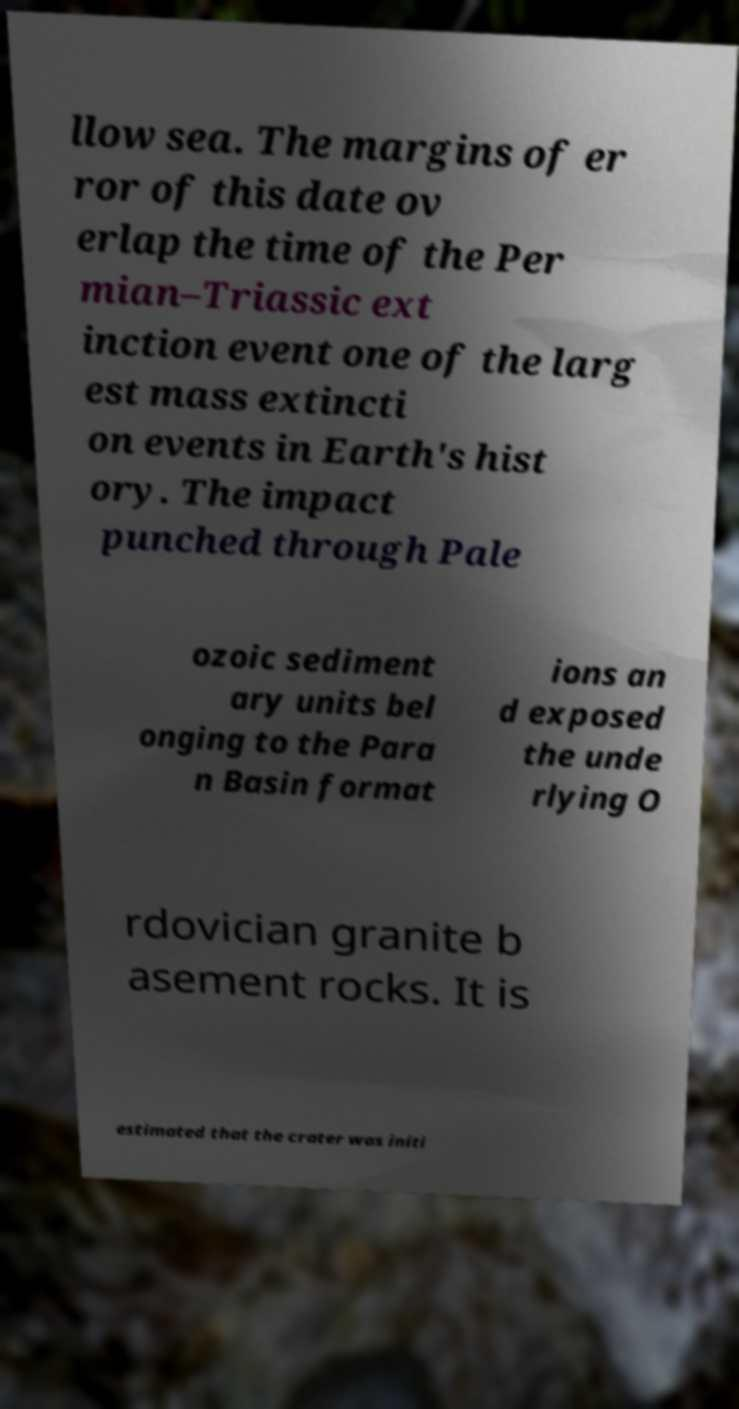There's text embedded in this image that I need extracted. Can you transcribe it verbatim? llow sea. The margins of er ror of this date ov erlap the time of the Per mian–Triassic ext inction event one of the larg est mass extincti on events in Earth's hist ory. The impact punched through Pale ozoic sediment ary units bel onging to the Para n Basin format ions an d exposed the unde rlying O rdovician granite b asement rocks. It is estimated that the crater was initi 